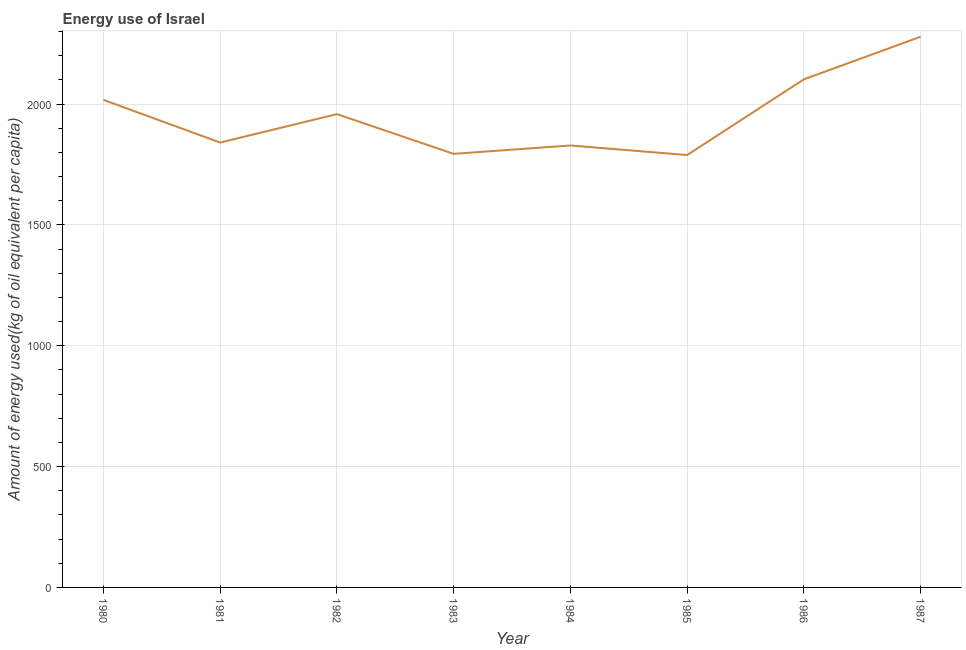What is the amount of energy used in 1984?
Your answer should be compact. 1828.54. Across all years, what is the maximum amount of energy used?
Your answer should be compact. 2278.48. Across all years, what is the minimum amount of energy used?
Offer a very short reply. 1789. In which year was the amount of energy used maximum?
Give a very brief answer. 1987. In which year was the amount of energy used minimum?
Offer a very short reply. 1985. What is the sum of the amount of energy used?
Provide a short and direct response. 1.56e+04. What is the difference between the amount of energy used in 1980 and 1986?
Provide a succinct answer. -84.97. What is the average amount of energy used per year?
Offer a terse response. 1951.06. What is the median amount of energy used?
Offer a very short reply. 1899.53. In how many years, is the amount of energy used greater than 500 kg?
Your answer should be very brief. 8. What is the ratio of the amount of energy used in 1983 to that in 1987?
Ensure brevity in your answer.  0.79. Is the amount of energy used in 1982 less than that in 1987?
Your response must be concise. Yes. What is the difference between the highest and the second highest amount of energy used?
Ensure brevity in your answer.  176.23. Is the sum of the amount of energy used in 1983 and 1986 greater than the maximum amount of energy used across all years?
Give a very brief answer. Yes. What is the difference between the highest and the lowest amount of energy used?
Offer a very short reply. 489.48. In how many years, is the amount of energy used greater than the average amount of energy used taken over all years?
Provide a short and direct response. 4. Does the amount of energy used monotonically increase over the years?
Keep it short and to the point. No. How many lines are there?
Make the answer very short. 1. What is the difference between two consecutive major ticks on the Y-axis?
Offer a very short reply. 500. What is the title of the graph?
Your response must be concise. Energy use of Israel. What is the label or title of the Y-axis?
Offer a terse response. Amount of energy used(kg of oil equivalent per capita). What is the Amount of energy used(kg of oil equivalent per capita) in 1980?
Provide a succinct answer. 2017.28. What is the Amount of energy used(kg of oil equivalent per capita) of 1981?
Your answer should be very brief. 1840.74. What is the Amount of energy used(kg of oil equivalent per capita) in 1982?
Your answer should be very brief. 1958.32. What is the Amount of energy used(kg of oil equivalent per capita) of 1983?
Make the answer very short. 1793.92. What is the Amount of energy used(kg of oil equivalent per capita) of 1984?
Keep it short and to the point. 1828.54. What is the Amount of energy used(kg of oil equivalent per capita) of 1985?
Make the answer very short. 1789. What is the Amount of energy used(kg of oil equivalent per capita) in 1986?
Provide a succinct answer. 2102.25. What is the Amount of energy used(kg of oil equivalent per capita) in 1987?
Offer a terse response. 2278.48. What is the difference between the Amount of energy used(kg of oil equivalent per capita) in 1980 and 1981?
Give a very brief answer. 176.54. What is the difference between the Amount of energy used(kg of oil equivalent per capita) in 1980 and 1982?
Your answer should be very brief. 58.96. What is the difference between the Amount of energy used(kg of oil equivalent per capita) in 1980 and 1983?
Keep it short and to the point. 223.35. What is the difference between the Amount of energy used(kg of oil equivalent per capita) in 1980 and 1984?
Offer a terse response. 188.74. What is the difference between the Amount of energy used(kg of oil equivalent per capita) in 1980 and 1985?
Ensure brevity in your answer.  228.28. What is the difference between the Amount of energy used(kg of oil equivalent per capita) in 1980 and 1986?
Provide a succinct answer. -84.97. What is the difference between the Amount of energy used(kg of oil equivalent per capita) in 1980 and 1987?
Your answer should be very brief. -261.2. What is the difference between the Amount of energy used(kg of oil equivalent per capita) in 1981 and 1982?
Your response must be concise. -117.58. What is the difference between the Amount of energy used(kg of oil equivalent per capita) in 1981 and 1983?
Give a very brief answer. 46.81. What is the difference between the Amount of energy used(kg of oil equivalent per capita) in 1981 and 1984?
Provide a short and direct response. 12.2. What is the difference between the Amount of energy used(kg of oil equivalent per capita) in 1981 and 1985?
Make the answer very short. 51.74. What is the difference between the Amount of energy used(kg of oil equivalent per capita) in 1981 and 1986?
Ensure brevity in your answer.  -261.51. What is the difference between the Amount of energy used(kg of oil equivalent per capita) in 1981 and 1987?
Offer a very short reply. -437.74. What is the difference between the Amount of energy used(kg of oil equivalent per capita) in 1982 and 1983?
Offer a very short reply. 164.4. What is the difference between the Amount of energy used(kg of oil equivalent per capita) in 1982 and 1984?
Provide a succinct answer. 129.78. What is the difference between the Amount of energy used(kg of oil equivalent per capita) in 1982 and 1985?
Your response must be concise. 169.32. What is the difference between the Amount of energy used(kg of oil equivalent per capita) in 1982 and 1986?
Give a very brief answer. -143.93. What is the difference between the Amount of energy used(kg of oil equivalent per capita) in 1982 and 1987?
Offer a terse response. -320.16. What is the difference between the Amount of energy used(kg of oil equivalent per capita) in 1983 and 1984?
Give a very brief answer. -34.62. What is the difference between the Amount of energy used(kg of oil equivalent per capita) in 1983 and 1985?
Provide a short and direct response. 4.93. What is the difference between the Amount of energy used(kg of oil equivalent per capita) in 1983 and 1986?
Provide a short and direct response. -308.32. What is the difference between the Amount of energy used(kg of oil equivalent per capita) in 1983 and 1987?
Give a very brief answer. -484.56. What is the difference between the Amount of energy used(kg of oil equivalent per capita) in 1984 and 1985?
Provide a succinct answer. 39.54. What is the difference between the Amount of energy used(kg of oil equivalent per capita) in 1984 and 1986?
Offer a terse response. -273.71. What is the difference between the Amount of energy used(kg of oil equivalent per capita) in 1984 and 1987?
Your answer should be very brief. -449.94. What is the difference between the Amount of energy used(kg of oil equivalent per capita) in 1985 and 1986?
Provide a short and direct response. -313.25. What is the difference between the Amount of energy used(kg of oil equivalent per capita) in 1985 and 1987?
Offer a very short reply. -489.48. What is the difference between the Amount of energy used(kg of oil equivalent per capita) in 1986 and 1987?
Give a very brief answer. -176.23. What is the ratio of the Amount of energy used(kg of oil equivalent per capita) in 1980 to that in 1981?
Your answer should be compact. 1.1. What is the ratio of the Amount of energy used(kg of oil equivalent per capita) in 1980 to that in 1984?
Give a very brief answer. 1.1. What is the ratio of the Amount of energy used(kg of oil equivalent per capita) in 1980 to that in 1985?
Your answer should be compact. 1.13. What is the ratio of the Amount of energy used(kg of oil equivalent per capita) in 1980 to that in 1986?
Keep it short and to the point. 0.96. What is the ratio of the Amount of energy used(kg of oil equivalent per capita) in 1980 to that in 1987?
Your response must be concise. 0.89. What is the ratio of the Amount of energy used(kg of oil equivalent per capita) in 1981 to that in 1982?
Your response must be concise. 0.94. What is the ratio of the Amount of energy used(kg of oil equivalent per capita) in 1981 to that in 1985?
Provide a succinct answer. 1.03. What is the ratio of the Amount of energy used(kg of oil equivalent per capita) in 1981 to that in 1986?
Provide a short and direct response. 0.88. What is the ratio of the Amount of energy used(kg of oil equivalent per capita) in 1981 to that in 1987?
Your answer should be compact. 0.81. What is the ratio of the Amount of energy used(kg of oil equivalent per capita) in 1982 to that in 1983?
Your answer should be very brief. 1.09. What is the ratio of the Amount of energy used(kg of oil equivalent per capita) in 1982 to that in 1984?
Provide a short and direct response. 1.07. What is the ratio of the Amount of energy used(kg of oil equivalent per capita) in 1982 to that in 1985?
Provide a short and direct response. 1.09. What is the ratio of the Amount of energy used(kg of oil equivalent per capita) in 1982 to that in 1986?
Your answer should be very brief. 0.93. What is the ratio of the Amount of energy used(kg of oil equivalent per capita) in 1982 to that in 1987?
Ensure brevity in your answer.  0.86. What is the ratio of the Amount of energy used(kg of oil equivalent per capita) in 1983 to that in 1986?
Provide a succinct answer. 0.85. What is the ratio of the Amount of energy used(kg of oil equivalent per capita) in 1983 to that in 1987?
Your answer should be compact. 0.79. What is the ratio of the Amount of energy used(kg of oil equivalent per capita) in 1984 to that in 1986?
Give a very brief answer. 0.87. What is the ratio of the Amount of energy used(kg of oil equivalent per capita) in 1984 to that in 1987?
Your answer should be very brief. 0.8. What is the ratio of the Amount of energy used(kg of oil equivalent per capita) in 1985 to that in 1986?
Keep it short and to the point. 0.85. What is the ratio of the Amount of energy used(kg of oil equivalent per capita) in 1985 to that in 1987?
Give a very brief answer. 0.79. What is the ratio of the Amount of energy used(kg of oil equivalent per capita) in 1986 to that in 1987?
Offer a very short reply. 0.92. 